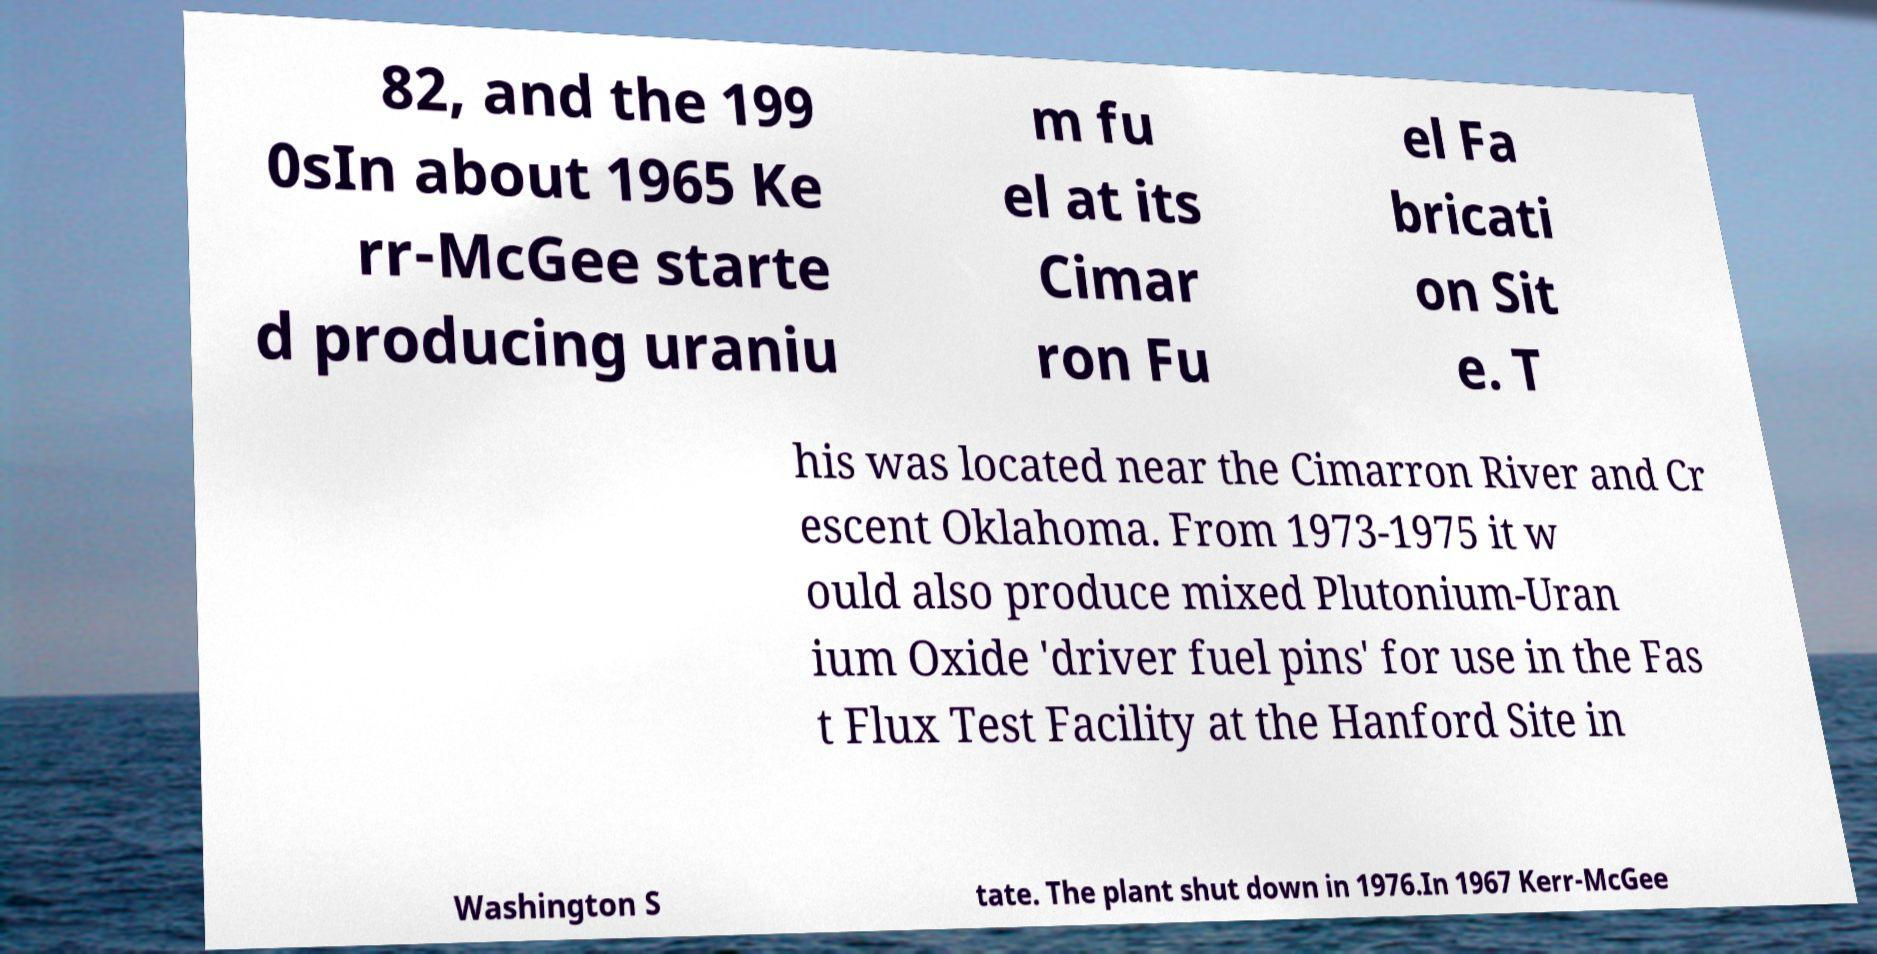Please identify and transcribe the text found in this image. 82, and the 199 0sIn about 1965 Ke rr-McGee starte d producing uraniu m fu el at its Cimar ron Fu el Fa bricati on Sit e. T his was located near the Cimarron River and Cr escent Oklahoma. From 1973-1975 it w ould also produce mixed Plutonium-Uran ium Oxide 'driver fuel pins' for use in the Fas t Flux Test Facility at the Hanford Site in Washington S tate. The plant shut down in 1976.In 1967 Kerr-McGee 